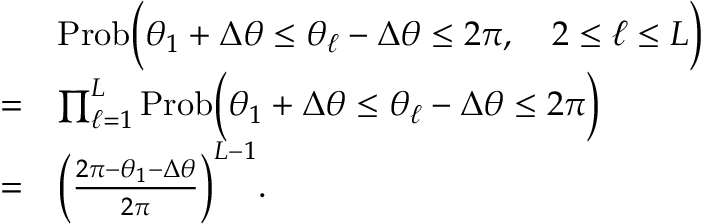Convert formula to latex. <formula><loc_0><loc_0><loc_500><loc_500>\begin{array} { r l } & { P r o b \left ( \theta _ { 1 } + \Delta \theta \leq \theta _ { \ell } - \Delta \theta \leq 2 \pi , \quad 2 \leq \ell \leq L \right ) } \\ { = } & { \prod _ { \ell = 1 } ^ { L } P r o b \left ( \theta _ { 1 } + \Delta \theta \leq \theta _ { \ell } - \Delta \theta \leq 2 \pi \right ) } \\ { = } & { \left ( \frac { 2 \pi - \theta _ { 1 } - \Delta \theta } { 2 \pi } \right ) ^ { L - 1 } . } \end{array}</formula> 